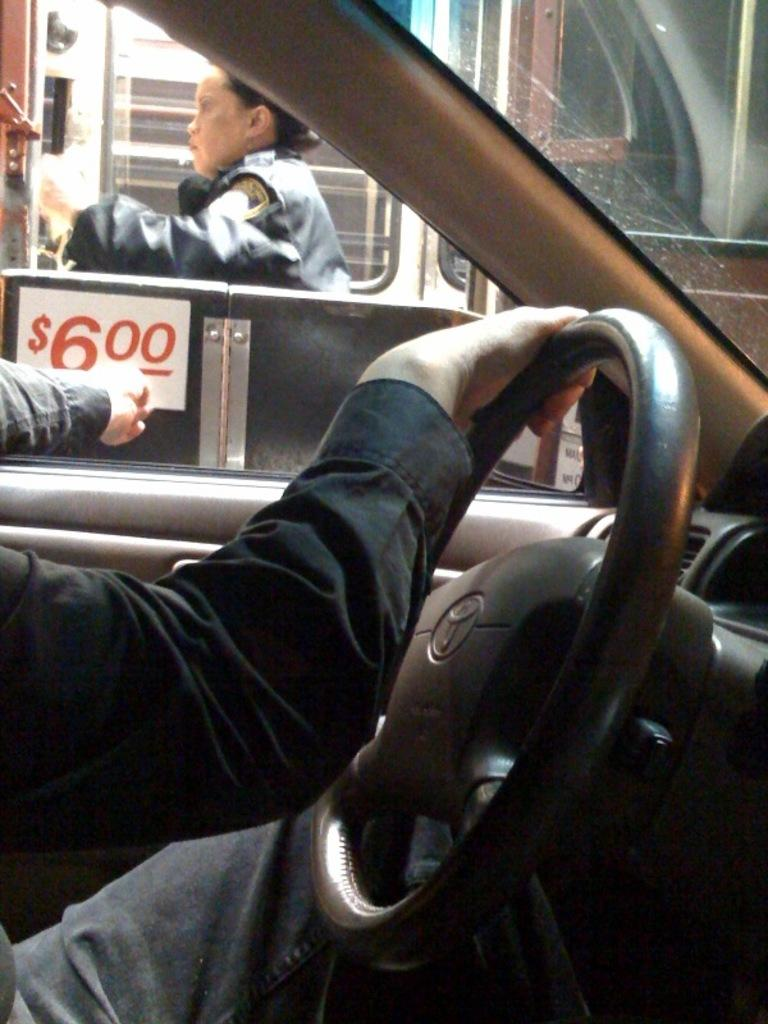What is the man inside the car doing? The man is wearing a black shirt and has his hand on the steering wheel. Can you describe the lady standing outside the car door? There is no specific description of the lady provided, but she is standing outside the car door. What color shirt is the man wearing? The man is wearing a black shirt. What type of cap is the spy wearing in the image? There is no spy or cap present in the image. 